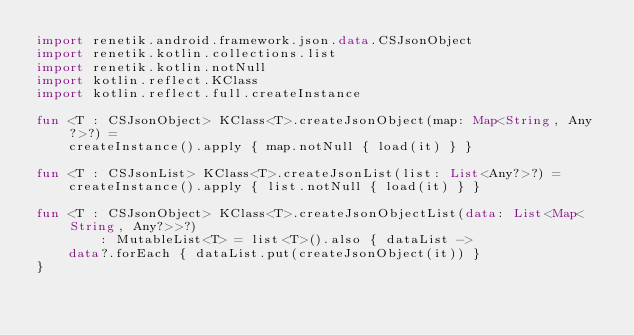Convert code to text. <code><loc_0><loc_0><loc_500><loc_500><_Kotlin_>import renetik.android.framework.json.data.CSJsonObject
import renetik.kotlin.collections.list
import renetik.kotlin.notNull
import kotlin.reflect.KClass
import kotlin.reflect.full.createInstance

fun <T : CSJsonObject> KClass<T>.createJsonObject(map: Map<String, Any?>?) =
    createInstance().apply { map.notNull { load(it) } }

fun <T : CSJsonList> KClass<T>.createJsonList(list: List<Any?>?) =
    createInstance().apply { list.notNull { load(it) } }

fun <T : CSJsonObject> KClass<T>.createJsonObjectList(data: List<Map<String, Any?>>?)
        : MutableList<T> = list<T>().also { dataList ->
    data?.forEach { dataList.put(createJsonObject(it)) }
}</code> 